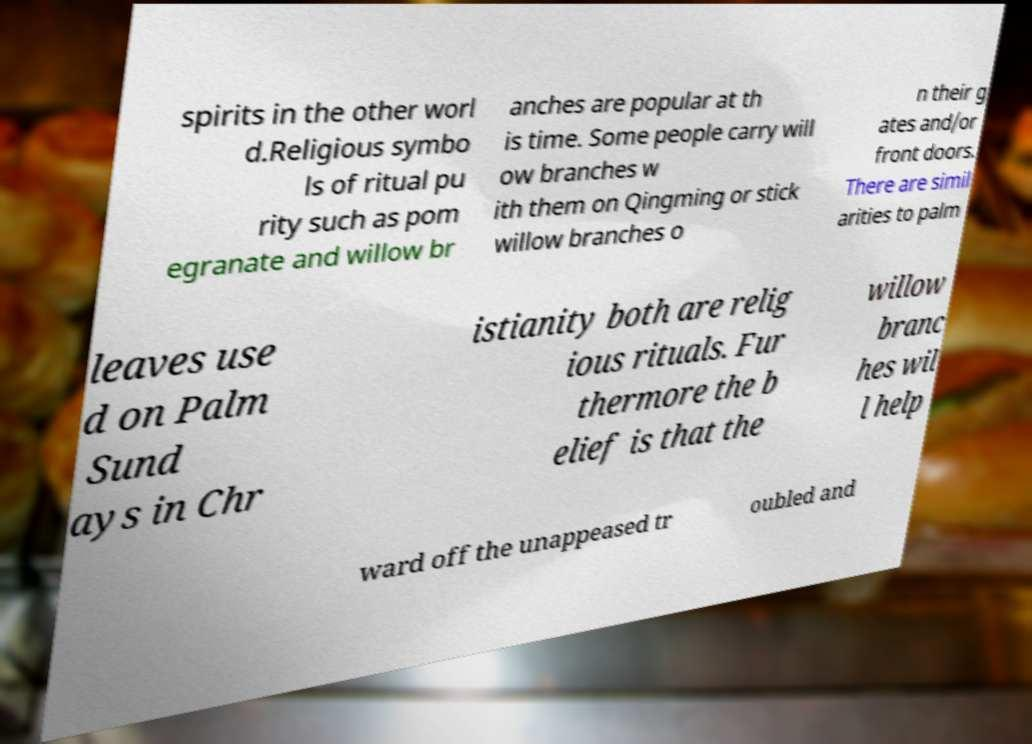Please identify and transcribe the text found in this image. spirits in the other worl d.Religious symbo ls of ritual pu rity such as pom egranate and willow br anches are popular at th is time. Some people carry will ow branches w ith them on Qingming or stick willow branches o n their g ates and/or front doors. There are simil arities to palm leaves use d on Palm Sund ays in Chr istianity both are relig ious rituals. Fur thermore the b elief is that the willow branc hes wil l help ward off the unappeased tr oubled and 